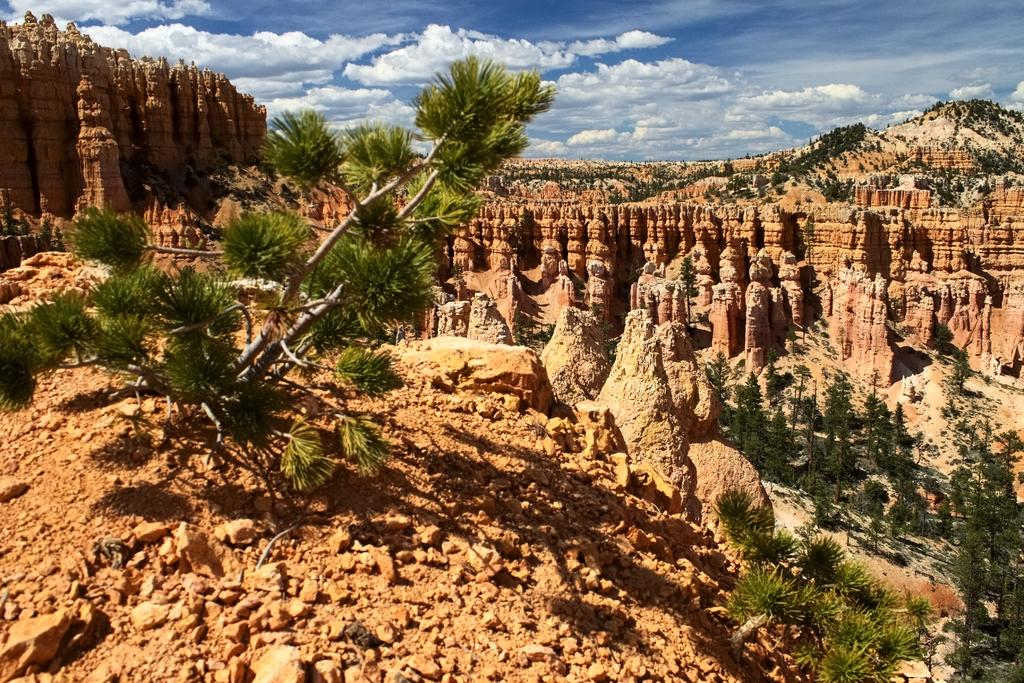What type of landscape is depicted in the image? The image features many hills. What type of vegetation can be seen in the image? There are trees in the image. How are the trees positioned in relation to the hills? The trees are located in between the hills. Can you tell me who the guide is leading through the hills in the image? There is no guide or any indication of a guided tour in the image. What type of basin is visible at the top of the hills in the image? There is no basin present in the image; it features hills and trees. 